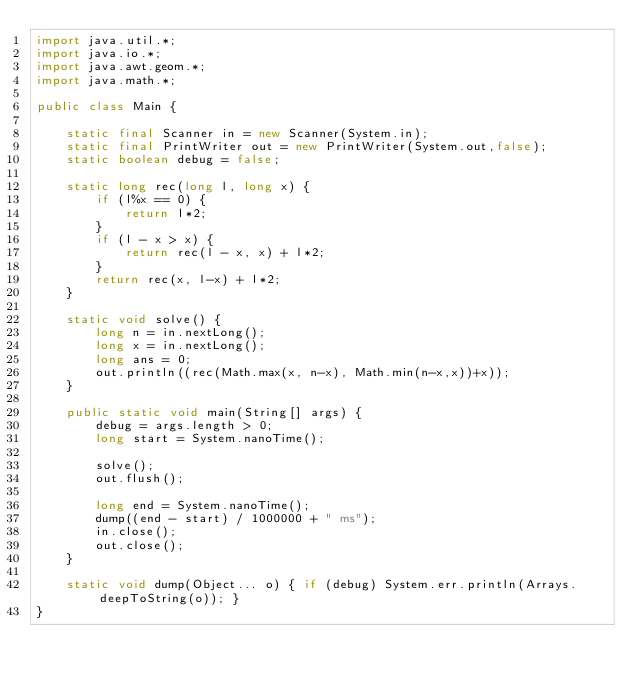Convert code to text. <code><loc_0><loc_0><loc_500><loc_500><_Java_>import java.util.*;
import java.io.*;
import java.awt.geom.*;
import java.math.*;

public class Main {

	static final Scanner in = new Scanner(System.in);
	static final PrintWriter out = new PrintWriter(System.out,false);
	static boolean debug = false;

	static long rec(long l, long x) {
		if (l%x == 0) {
			return l*2;
		}
		if (l - x > x) {
			return rec(l - x, x) + l*2;
		}
		return rec(x, l-x) + l*2;
	}

	static void solve() {
		long n = in.nextLong();
	 	long x = in.nextLong();
	 	long ans = 0;
	 	out.println((rec(Math.max(x, n-x), Math.min(n-x,x))+x));
	}

	public static void main(String[] args) {
		debug = args.length > 0;
		long start = System.nanoTime();

		solve();
		out.flush();

		long end = System.nanoTime();
		dump((end - start) / 1000000 + " ms");
		in.close();
		out.close();
	}

	static void dump(Object... o) { if (debug) System.err.println(Arrays.deepToString(o)); }
}</code> 